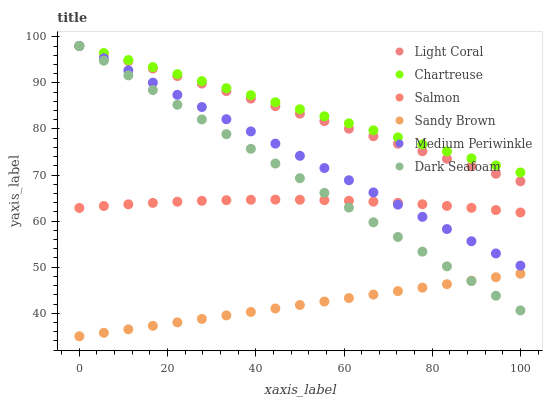Does Sandy Brown have the minimum area under the curve?
Answer yes or no. Yes. Does Chartreuse have the maximum area under the curve?
Answer yes or no. Yes. Does Salmon have the minimum area under the curve?
Answer yes or no. No. Does Salmon have the maximum area under the curve?
Answer yes or no. No. Is Sandy Brown the smoothest?
Answer yes or no. Yes. Is Salmon the roughest?
Answer yes or no. Yes. Is Dark Seafoam the smoothest?
Answer yes or no. No. Is Dark Seafoam the roughest?
Answer yes or no. No. Does Sandy Brown have the lowest value?
Answer yes or no. Yes. Does Salmon have the lowest value?
Answer yes or no. No. Does Chartreuse have the highest value?
Answer yes or no. Yes. Does Salmon have the highest value?
Answer yes or no. No. Is Sandy Brown less than Light Coral?
Answer yes or no. Yes. Is Medium Periwinkle greater than Sandy Brown?
Answer yes or no. Yes. Does Medium Periwinkle intersect Light Coral?
Answer yes or no. Yes. Is Medium Periwinkle less than Light Coral?
Answer yes or no. No. Is Medium Periwinkle greater than Light Coral?
Answer yes or no. No. Does Sandy Brown intersect Light Coral?
Answer yes or no. No. 